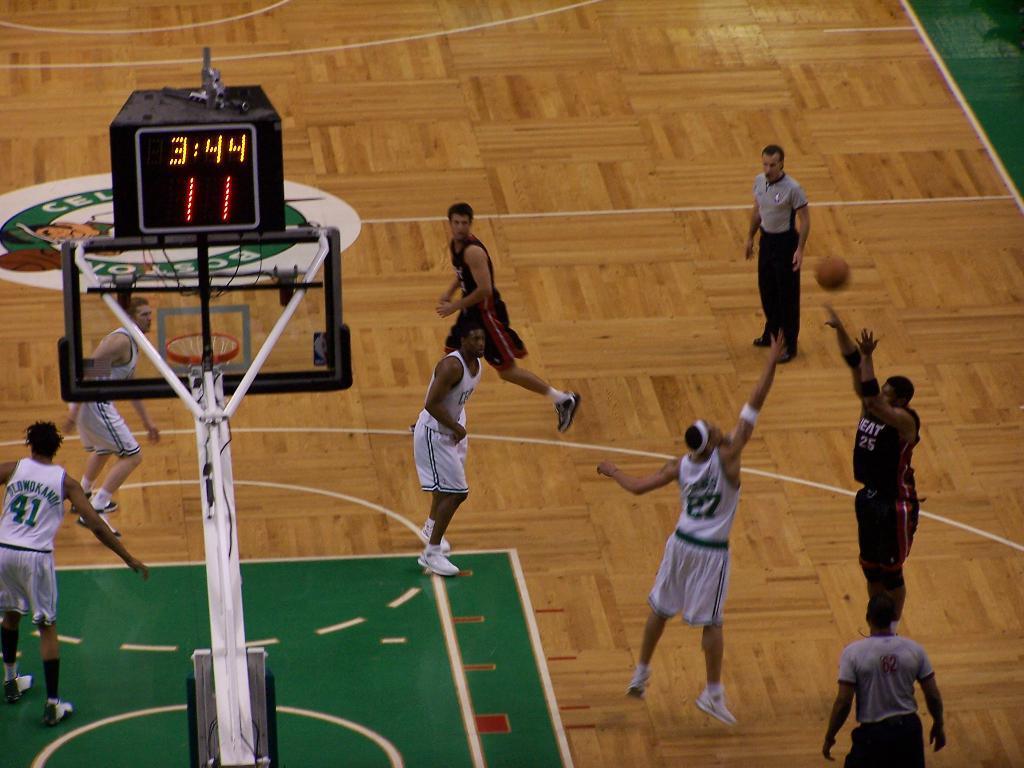Describe this image in one or two sentences. In this picture I can observe some players playing basketball in the court. I can observe white and black color jerseys in this picture. On the left side there is a basket fixed to the pole. I can observe LED display on the left side. The court is in brown color. 